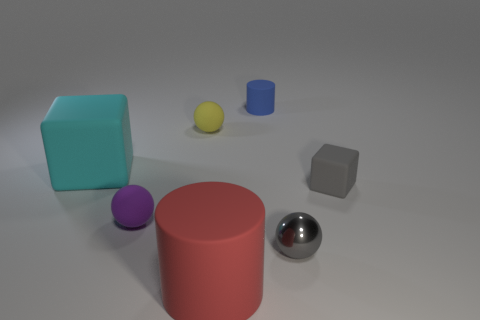Subtract all rubber spheres. How many spheres are left? 1 Add 2 rubber objects. How many objects exist? 9 Subtract all cubes. How many objects are left? 5 Subtract all blue cylinders. Subtract all big rubber blocks. How many objects are left? 5 Add 6 blue objects. How many blue objects are left? 7 Add 1 blue matte cylinders. How many blue matte cylinders exist? 2 Subtract 0 cyan cylinders. How many objects are left? 7 Subtract all blue cylinders. Subtract all yellow cubes. How many cylinders are left? 1 